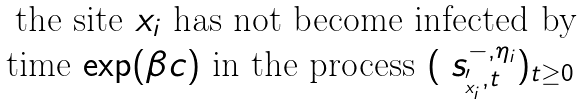Convert formula to latex. <formula><loc_0><loc_0><loc_500><loc_500>\begin{matrix} \text { the site $x_{i}$ has not become infected by} \\ \text {time $\exp(\beta c)$} \text { in the process } ( \ s _ { \L ^ { \prime } _ { x _ { i } } , t } ^ { - , \eta _ { i } } ) _ { t \geq 0 } \end{matrix}</formula> 